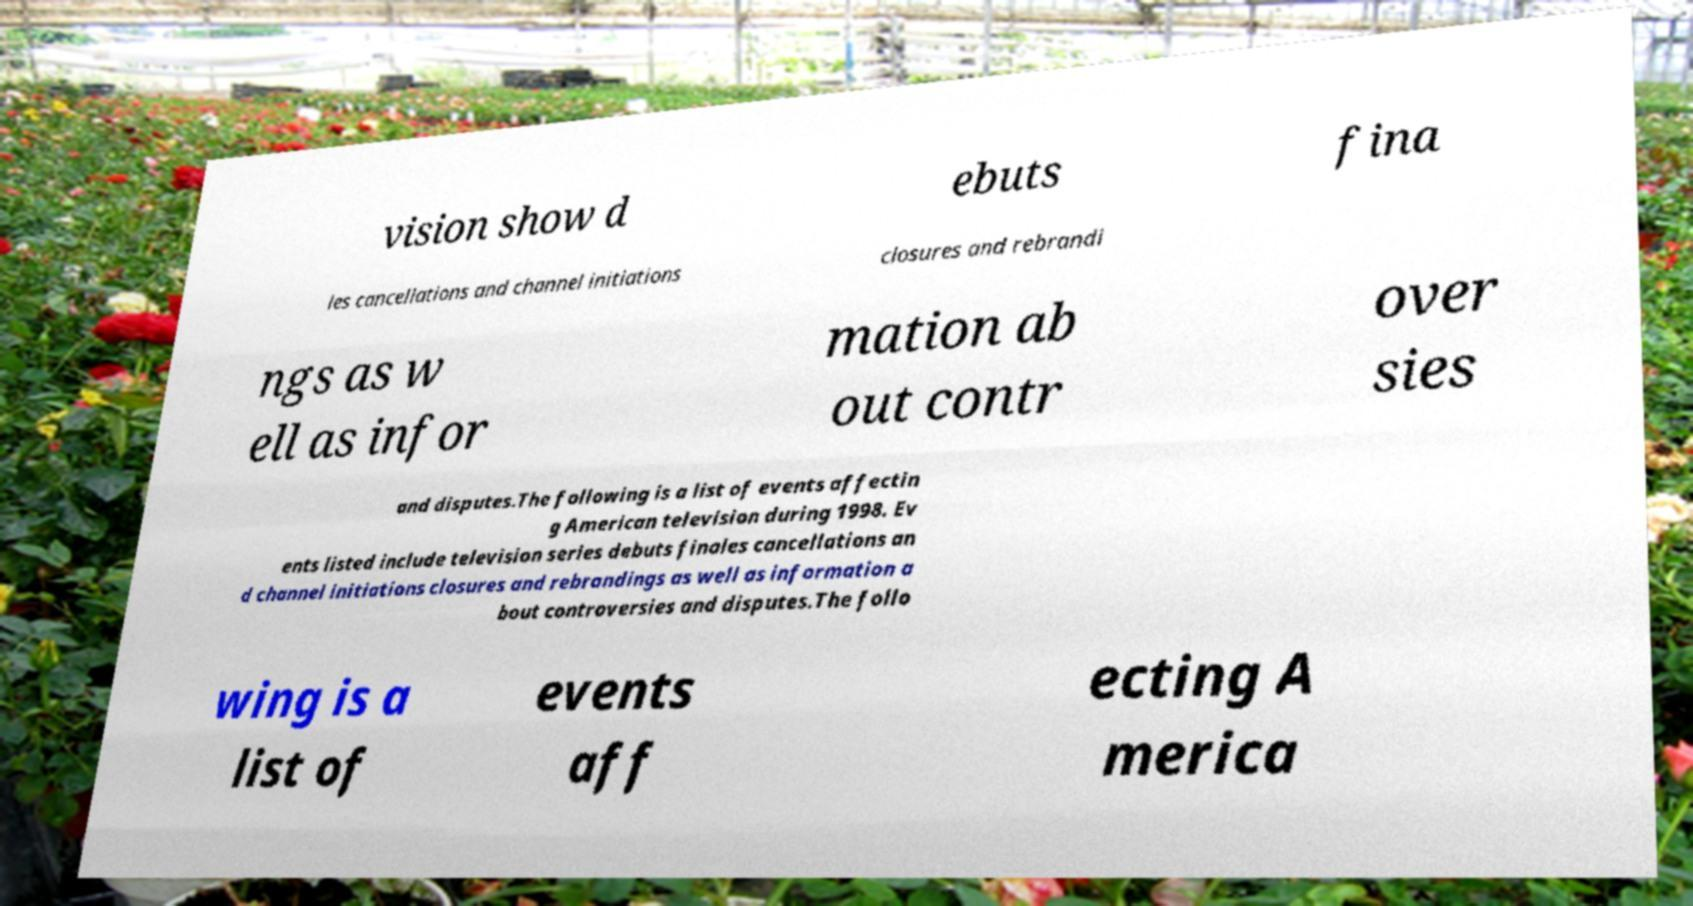Could you assist in decoding the text presented in this image and type it out clearly? vision show d ebuts fina les cancellations and channel initiations closures and rebrandi ngs as w ell as infor mation ab out contr over sies and disputes.The following is a list of events affectin g American television during 1998. Ev ents listed include television series debuts finales cancellations an d channel initiations closures and rebrandings as well as information a bout controversies and disputes.The follo wing is a list of events aff ecting A merica 